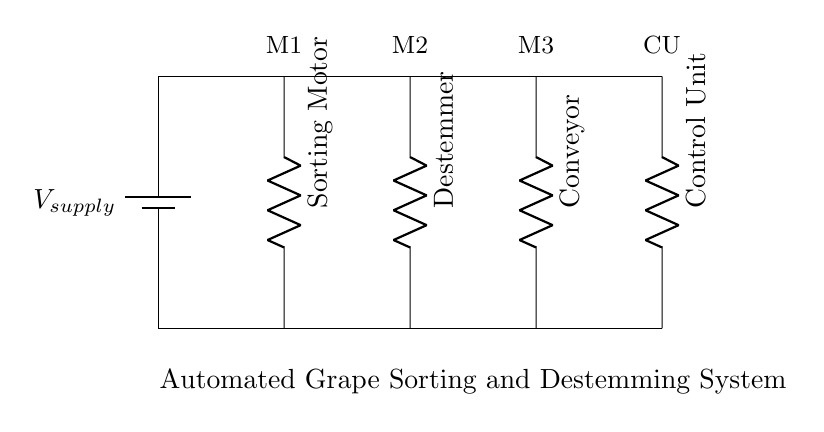What type of circuit is shown? The circuit diagram displays a parallel circuit, where all components are connected across the same voltage source. This means that each component operates independently of the others.
Answer: Parallel circuit How many components are in the circuit? There are four components in the circuit diagram: a sorting motor, a destemmer, a conveyor, and a control unit. Each of these is represented by a resistor symbol in the circuit.
Answer: Four What does the sorting motor do? The sorting motor's purpose is to automate the sorting of grapes, making it a critical component in the grape sorting process. Its function is represented in the circuit as one of the parallel connections from the voltage source.
Answer: Automate sorting What is the function of the control unit? The control unit manages the operations of the entire system, coordinating how other components operate in relation to each other. It is connected in parallel and acts as the brain of the automated system.
Answer: Manages operations If one component fails, what happens to the others? In a parallel circuit, if one component fails (for instance, the sorting motor), the other components continue to function normally because they are connected independently to the same power source.
Answer: They continue to function What is the implication of using a parallel connection for this system? Using a parallel connection allows each component to operate independently, enhancing the reliability of the system. Therefore, if one component stops working, it does not affect the operation of the other components, which is crucial for continuous operations in winemaking.
Answer: Enhanced reliability 